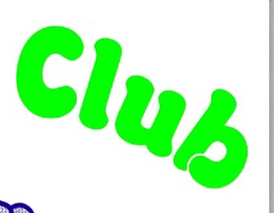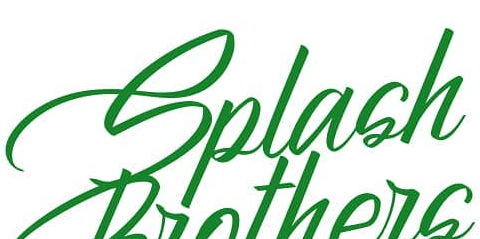What words are shown in these images in order, separated by a semicolon? Club; Splash 